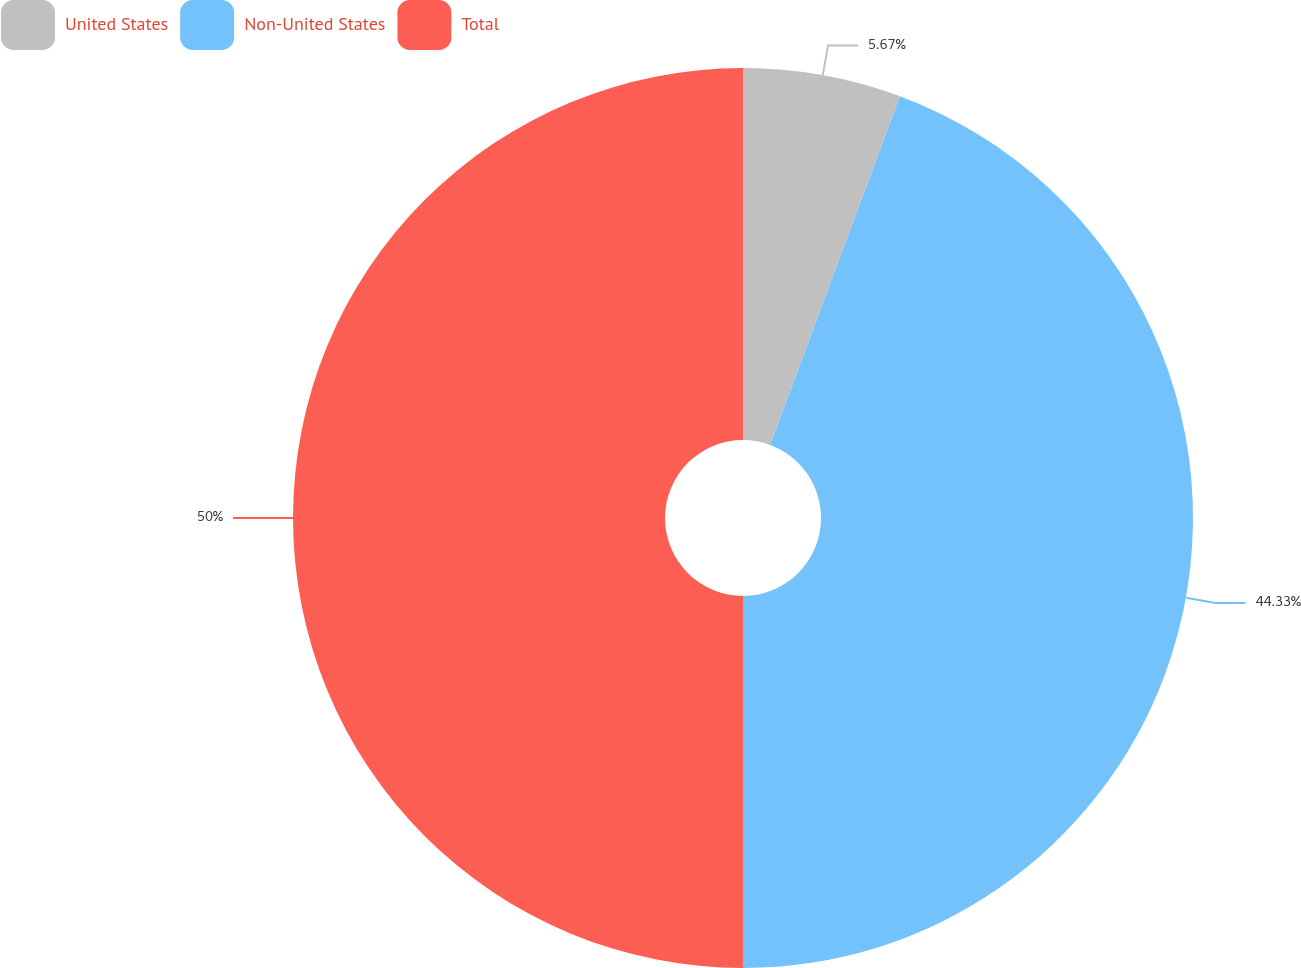Convert chart. <chart><loc_0><loc_0><loc_500><loc_500><pie_chart><fcel>United States<fcel>Non-United States<fcel>Total<nl><fcel>5.67%<fcel>44.33%<fcel>50.0%<nl></chart> 